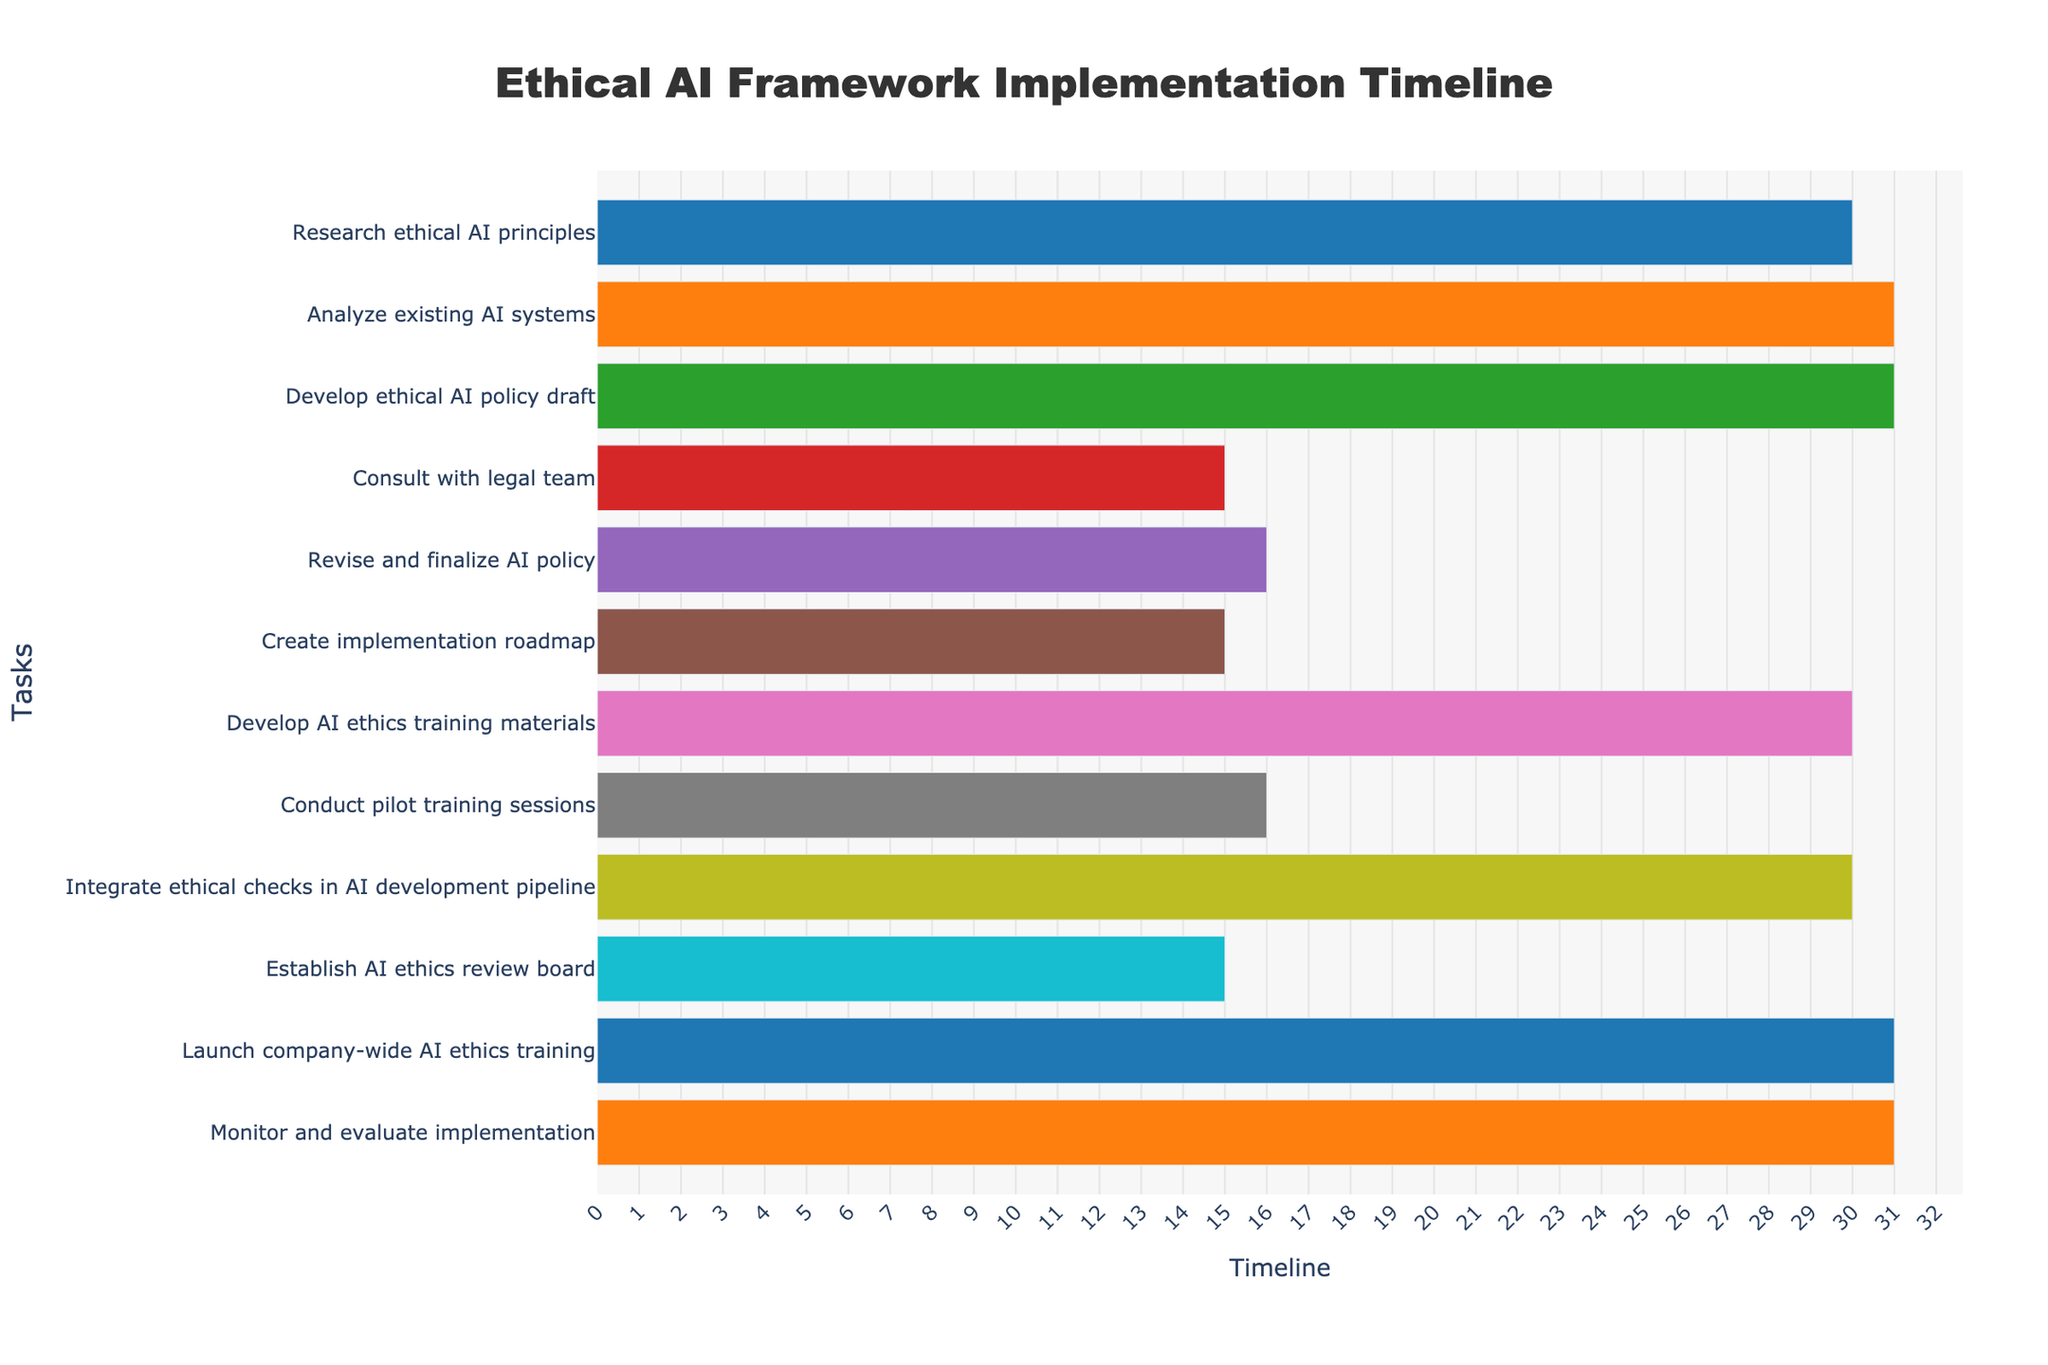What is the total duration of the "Analyze existing AI systems" task? The duration shown for the "Analyze existing AI systems" task is 31 days, which is stated directly on the figure.
Answer: 31 days When does the "Consult with legal team" task begin and end? The start and end dates are visualized on the figure. The task begins on August 1, 2023, and ends on August 15, 2023.
Answer: August 1, 2023, to August 15, 2023 Which task has the longest duration and what is it? Observing the durations of each task in the figure, "Analyze existing AI systems" and "Develop AI ethics training materials" both have the longest duration of 31 days.
Answer: Analyze existing AI systems and Develop AI ethics training materials How many tasks are scheduled to finish before September 1, 2023? By looking at the end dates of the tasks in the figure, the tasks finishing before September 1, 2023, are: "Research ethical AI principles", "Analyze existing AI systems", "Develop ethical AI policy draft", "Consult with legal team", and "Revise and finalize AI policy". This sums up to 5 tasks.
Answer: 5 tasks When does the "Develop AI ethics training materials" task start and end? The start and end dates are visualized on the figure. The task begins on September 16, 2023, and ends on October 15, 2023.
Answer: September 16, 2023, to October 15, 2023 Which task directly follows "Consult with legal team"? By following the timeline on the figure, the task "Revise and finalize AI policy" directly follows the task "Consult with legal team".
Answer: Revise and finalize AI policy Compare the duration of "Create implementation roadmap" with "Conduct pilot training sessions.” Which one is longer? Observing the durations of each task in the figure, "Create implementation roadmap" has a duration of 15 days, and "Conduct pilot training sessions" has a duration of 16 days. Thus, "Conduct pilot training sessions" is longer.
Answer: Conduct pilot training sessions What is the last task in the project and its duration? The last task listed and visualized in the figure is "Monitor and evaluate implementation," which has a duration of 31 days.
Answer: Monitor and evaluate implementation, 31 days How many tasks have a duration of exactly 30 days? Observing the durations of each task in the figure, the tasks with a duration of exactly 30 days are: "Research ethical AI principles", "Develop AI ethics training materials", and "Integrate ethical checks in AI development pipeline". This sums up to 3 tasks.
Answer: 3 tasks 